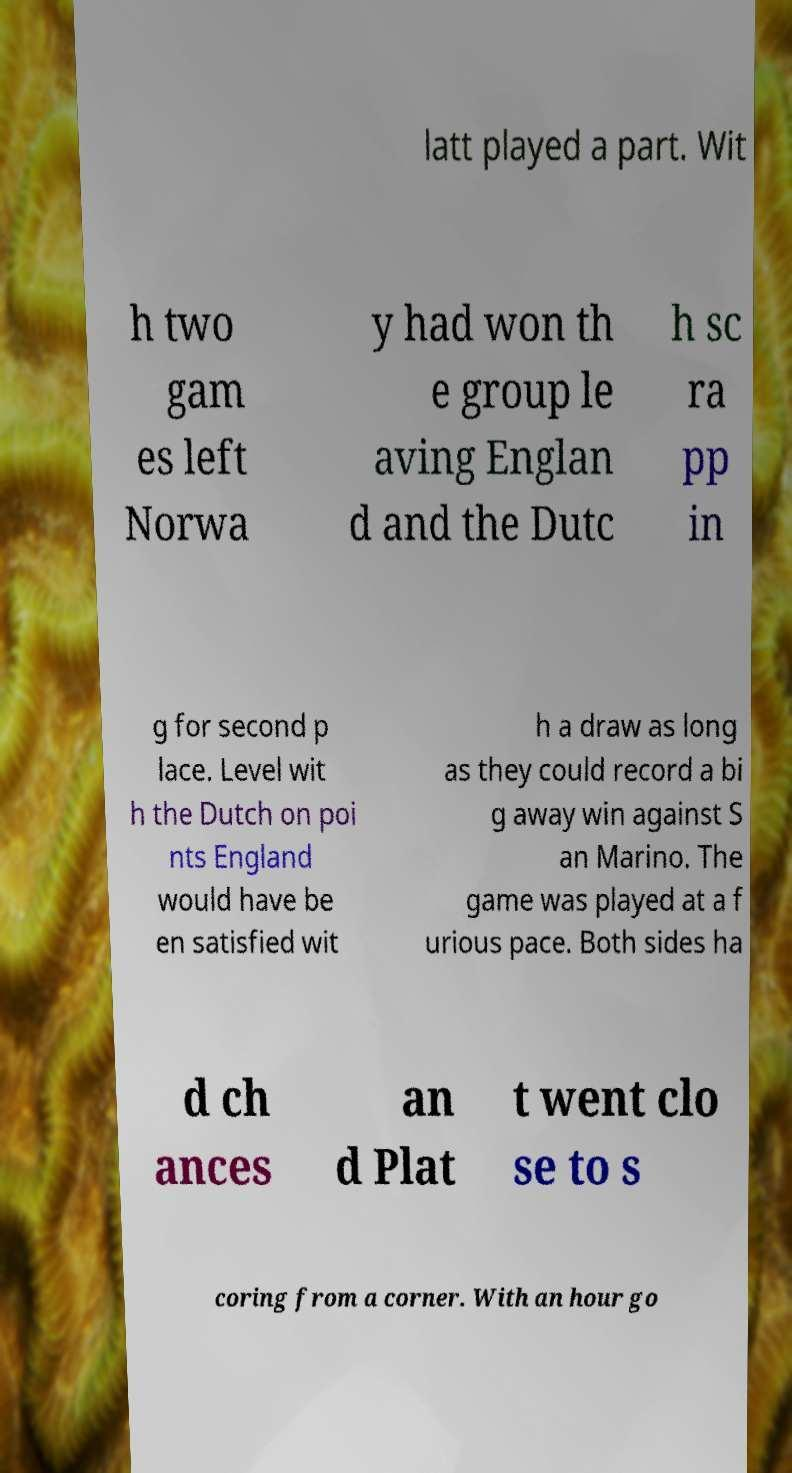There's text embedded in this image that I need extracted. Can you transcribe it verbatim? latt played a part. Wit h two gam es left Norwa y had won th e group le aving Englan d and the Dutc h sc ra pp in g for second p lace. Level wit h the Dutch on poi nts England would have be en satisfied wit h a draw as long as they could record a bi g away win against S an Marino. The game was played at a f urious pace. Both sides ha d ch ances an d Plat t went clo se to s coring from a corner. With an hour go 